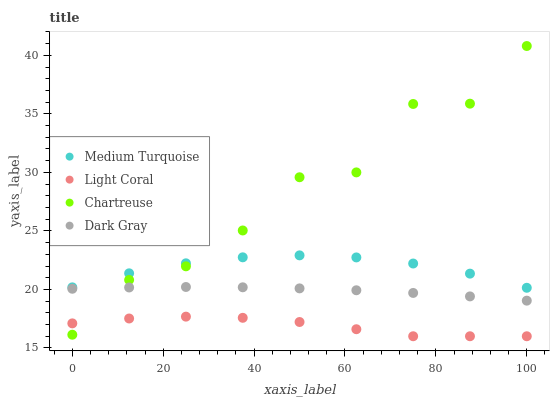Does Light Coral have the minimum area under the curve?
Answer yes or no. Yes. Does Chartreuse have the maximum area under the curve?
Answer yes or no. Yes. Does Dark Gray have the minimum area under the curve?
Answer yes or no. No. Does Dark Gray have the maximum area under the curve?
Answer yes or no. No. Is Dark Gray the smoothest?
Answer yes or no. Yes. Is Chartreuse the roughest?
Answer yes or no. Yes. Is Chartreuse the smoothest?
Answer yes or no. No. Is Dark Gray the roughest?
Answer yes or no. No. Does Light Coral have the lowest value?
Answer yes or no. Yes. Does Dark Gray have the lowest value?
Answer yes or no. No. Does Chartreuse have the highest value?
Answer yes or no. Yes. Does Dark Gray have the highest value?
Answer yes or no. No. Is Light Coral less than Medium Turquoise?
Answer yes or no. Yes. Is Medium Turquoise greater than Dark Gray?
Answer yes or no. Yes. Does Medium Turquoise intersect Chartreuse?
Answer yes or no. Yes. Is Medium Turquoise less than Chartreuse?
Answer yes or no. No. Is Medium Turquoise greater than Chartreuse?
Answer yes or no. No. Does Light Coral intersect Medium Turquoise?
Answer yes or no. No. 